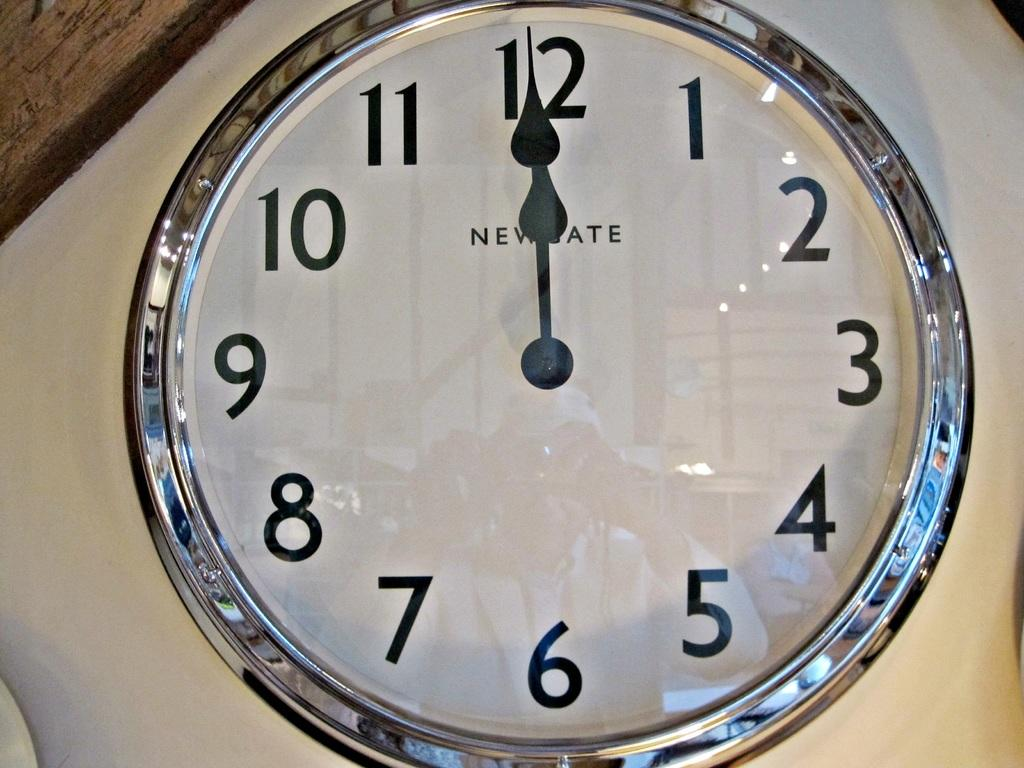<image>
Present a compact description of the photo's key features. A Newgate clock has the time at about noon. 